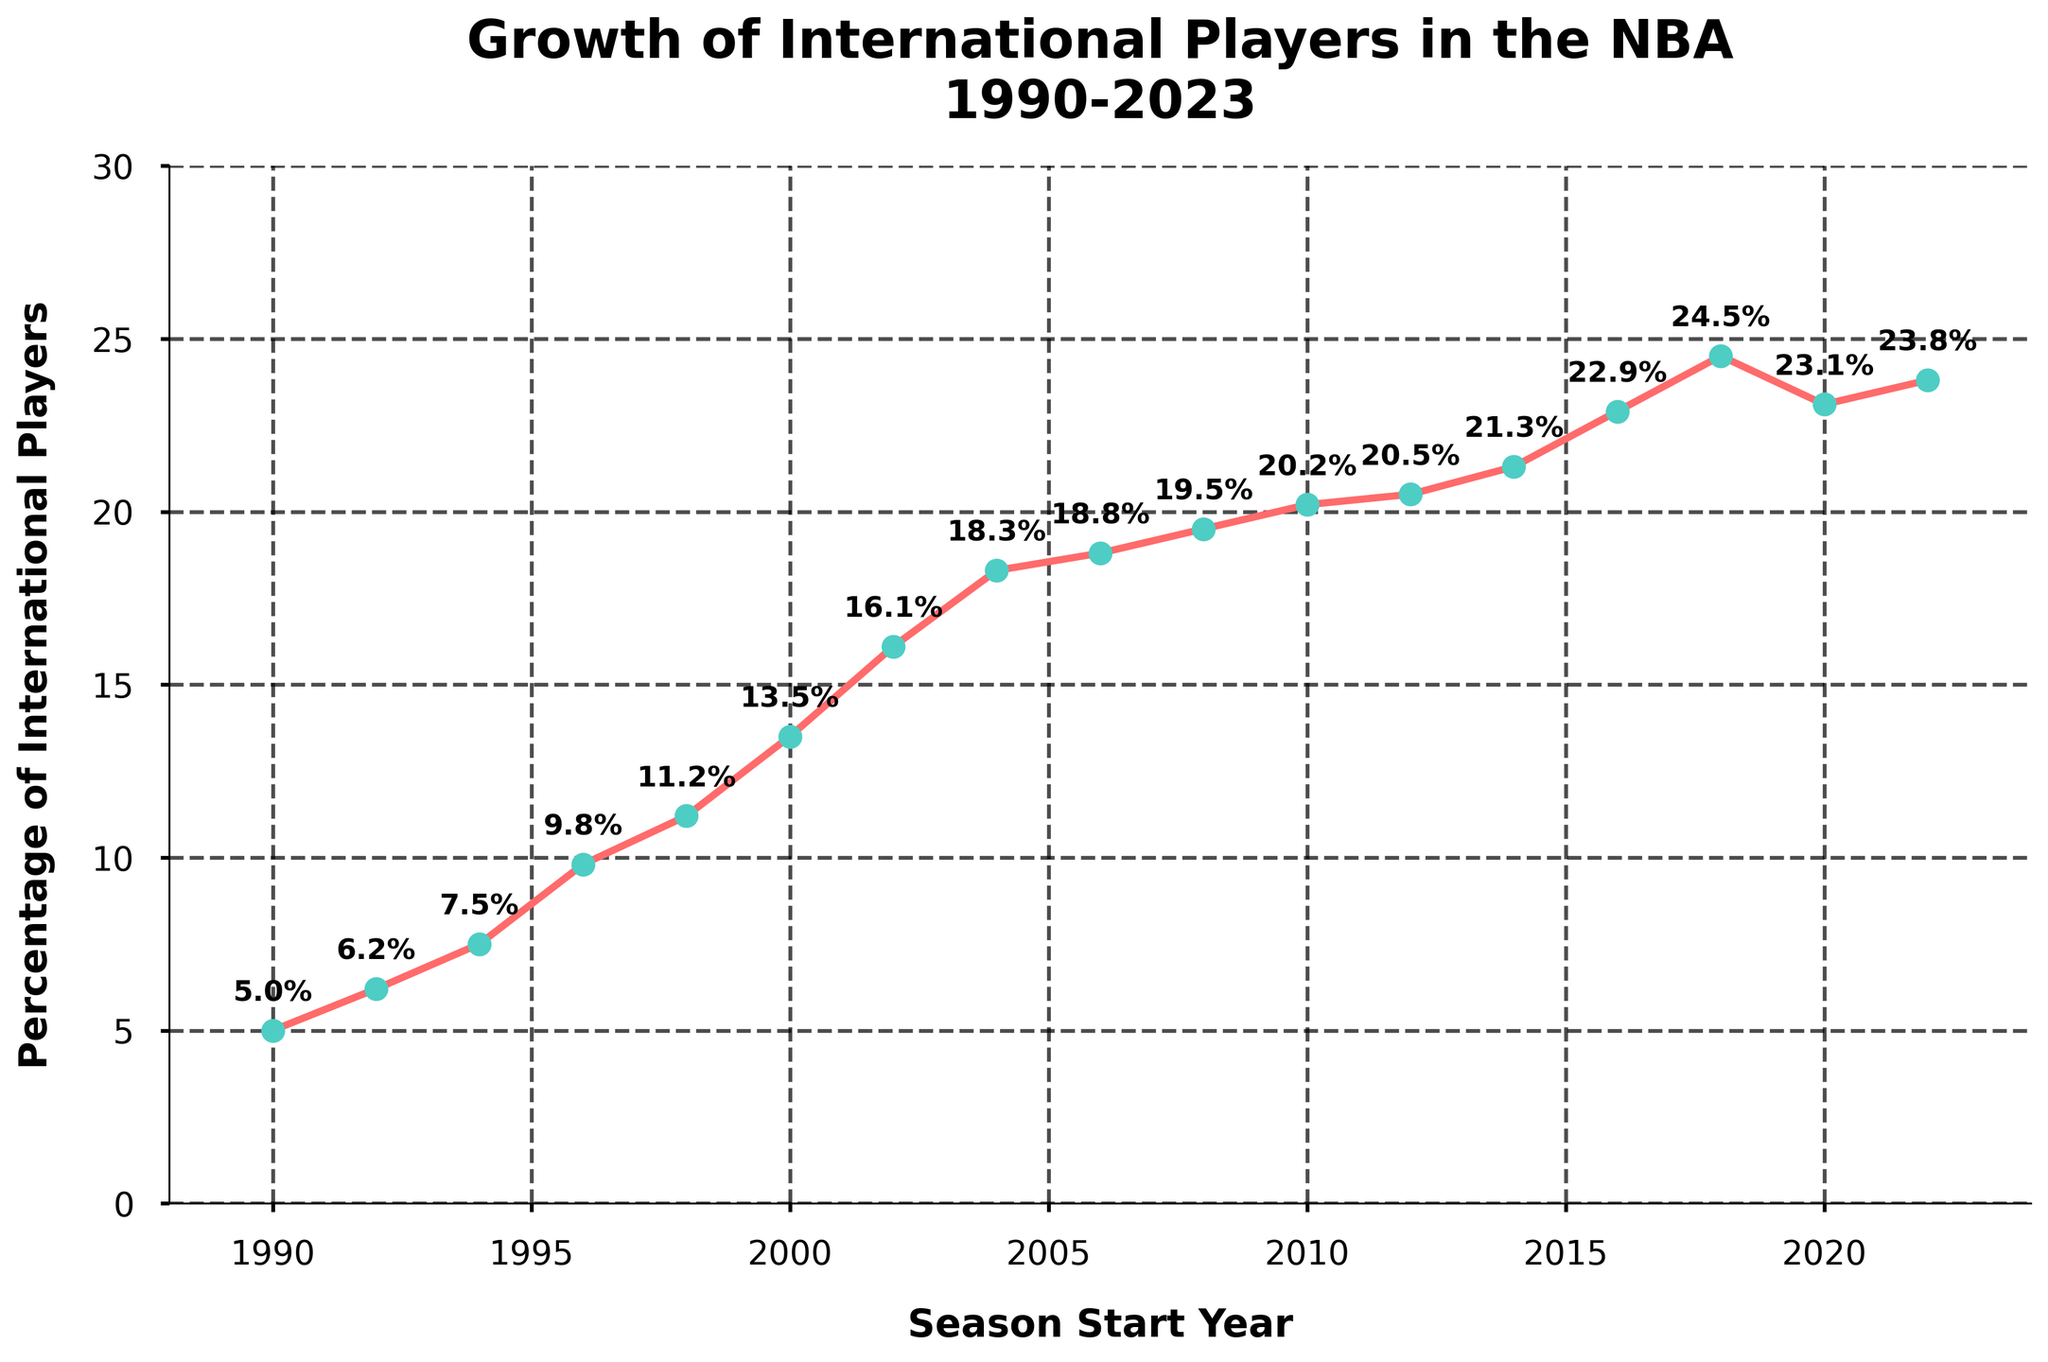What's the trend in the percentage of international players in the NBA from 1990 to 2023? Looking at the line chart, observe the trajectory from the starting point in 1990 to the endpoint in 2023. The line generally increases with some small fluctuations. The trend indicates a general upward trajectory over the years.
Answer: Increasing When did the percentage of international players first exceed 20%? Identify the points on the line and find the first instance where the percentage goes above 20. This happens in the season 2010-11.
Answer: 2010-11 Which season, between 2000 and 2010, had the highest percentage of international players? Focus on the data points between 2000-01 and 2010-11. Compare the percentages for each season visually. The highest percentage in this range is in the 2008-09 season with 19.5%.
Answer: 2008-09 How much did the percentage of international players increase from 1990-91 to 2000-01? Subtract the percentage in 1990-91 from the percentage in 2000-01: 13.5% - 5.0% = 8.5%.
Answer: 8.5% Did the percentage of international players ever decline from one season to the next? If so, when? Observe the line and look for any downward slopes. Notice that from 2018-19 (24.5%) to 2020-21 (23.1%) there is a decline.
Answer: Yes, from 2018-19 to 2020-21 Compare the growth rate in international players' percentage from 1990-91 to 2000-01 and from 2000-01 to 2010-11. Which period saw a higher increase? Calculate the increase for both periods: 1990-91 to 2000-01 increased by 8.5%, and 2000-01 to 2010-11 increased by 6.7%. Hence, the first period saw a higher increase.
Answer: 1990-91 to 2000-01 What was the percentage change from the 1998-99 season to the 2002-03 season? Find the percent change using the formula: ((New Percentage - Old Percentage) / Old Percentage) * 100. Here, ((16.1 - 11.2) / 11.2) * 100 = 43.75%.
Answer: 43.75% Which season witnessed the smallest percentage of international players in the NBA? Identify the lowest data point in the chart. The smallest percentage, 5.0%, is in the 1990-91 season.
Answer: 1990-91 Between which consecutive seasons from 1990-91 to 2022-23 did the percentage of international players increase the most? Examine the line and look for the steepest upward slope between consecutive points. The largest increase occurred from 2016-17 (22.9%) to 2018-19 (24.5%), an increase of 1.6%.
Answer: 2016-17 to 2018-19 